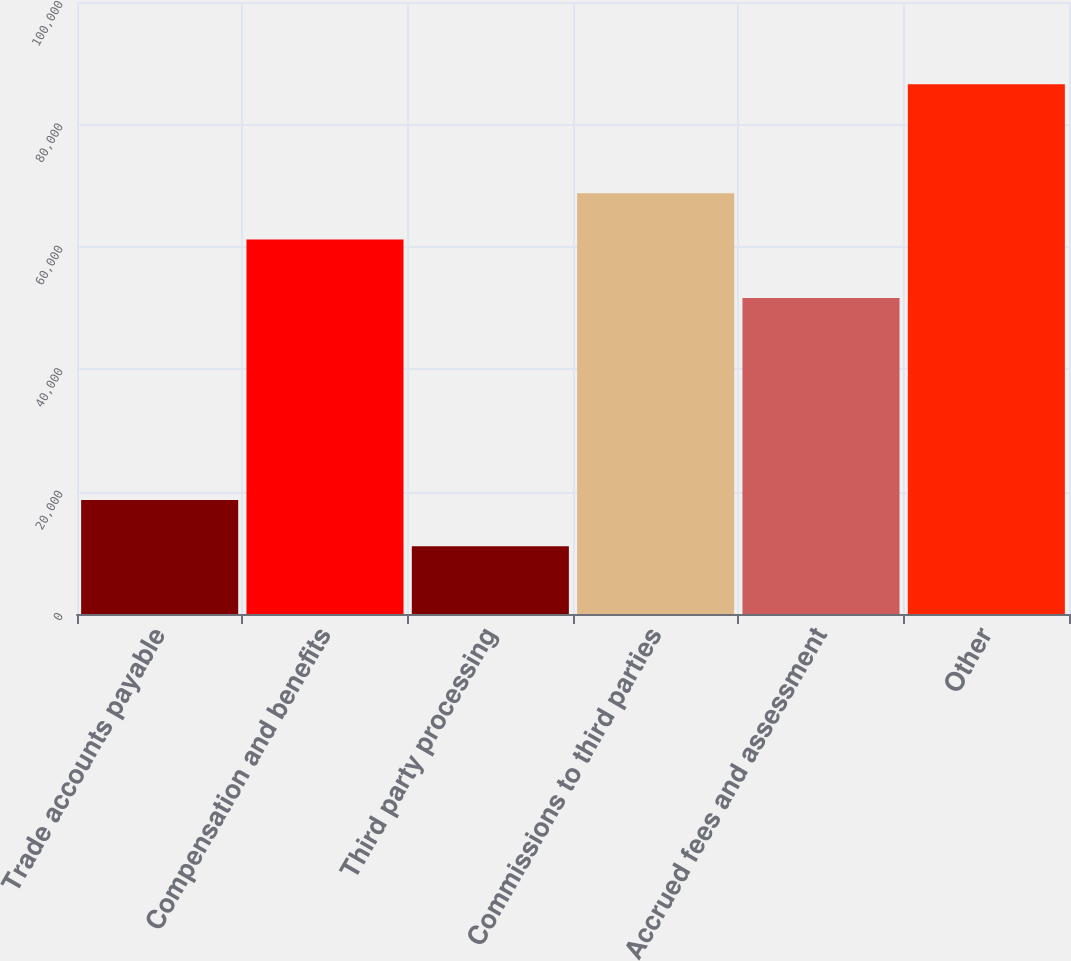Convert chart. <chart><loc_0><loc_0><loc_500><loc_500><bar_chart><fcel>Trade accounts payable<fcel>Compensation and benefits<fcel>Third party processing<fcel>Commissions to third parties<fcel>Accrued fees and assessment<fcel>Other<nl><fcel>18613.3<fcel>61193<fcel>11062<fcel>68744.3<fcel>51649<fcel>86575<nl></chart> 